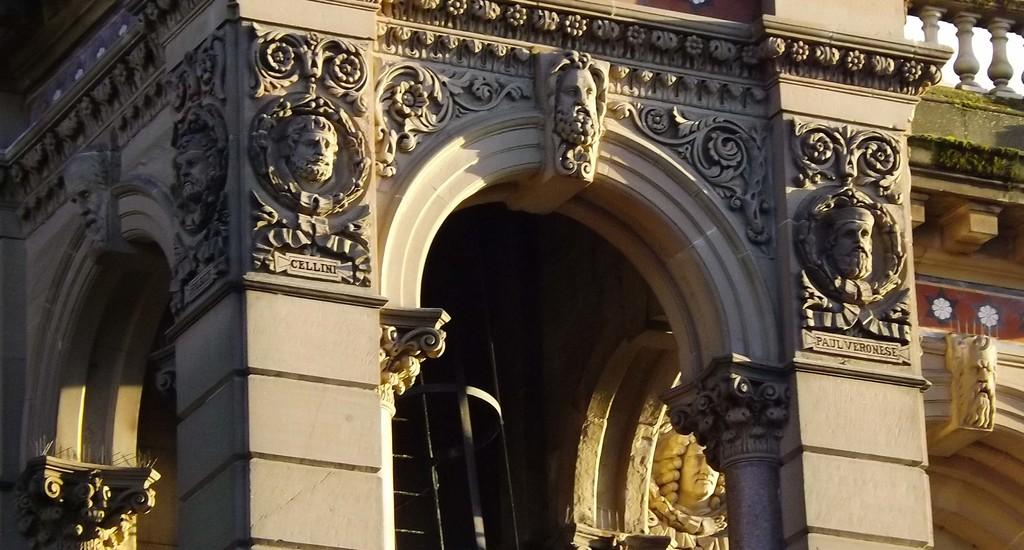What architectural features can be seen in the image? There are pillars in the image. What type of artwork is present on the wall in the image? There is a wall with sculpture carved on it in the image. How many times has the net been folded in the image? There is no net present in the image. What type of waste can be seen in the image? There is no waste present in the image. 